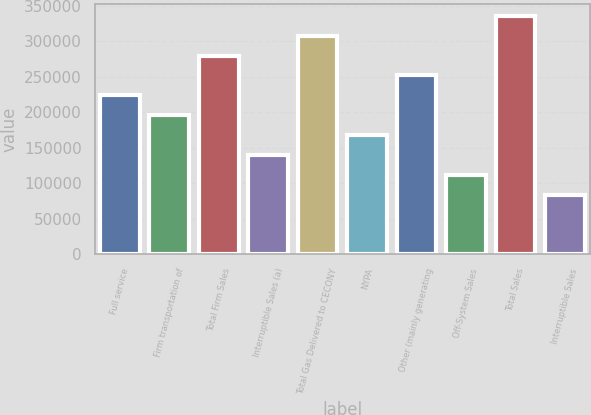Convert chart to OTSL. <chart><loc_0><loc_0><loc_500><loc_500><bar_chart><fcel>Full service<fcel>Firm transportation of<fcel>Total Firm Sales<fcel>Interruptible Sales (a)<fcel>Total Gas Delivered to CECONY<fcel>NYPA<fcel>Other (mainly generating<fcel>Off-System Sales<fcel>Total Sales<fcel>Interruptible Sales<nl><fcel>223798<fcel>195825<fcel>279745<fcel>139879<fcel>307718<fcel>167852<fcel>251772<fcel>111905<fcel>335692<fcel>83931.9<nl></chart> 